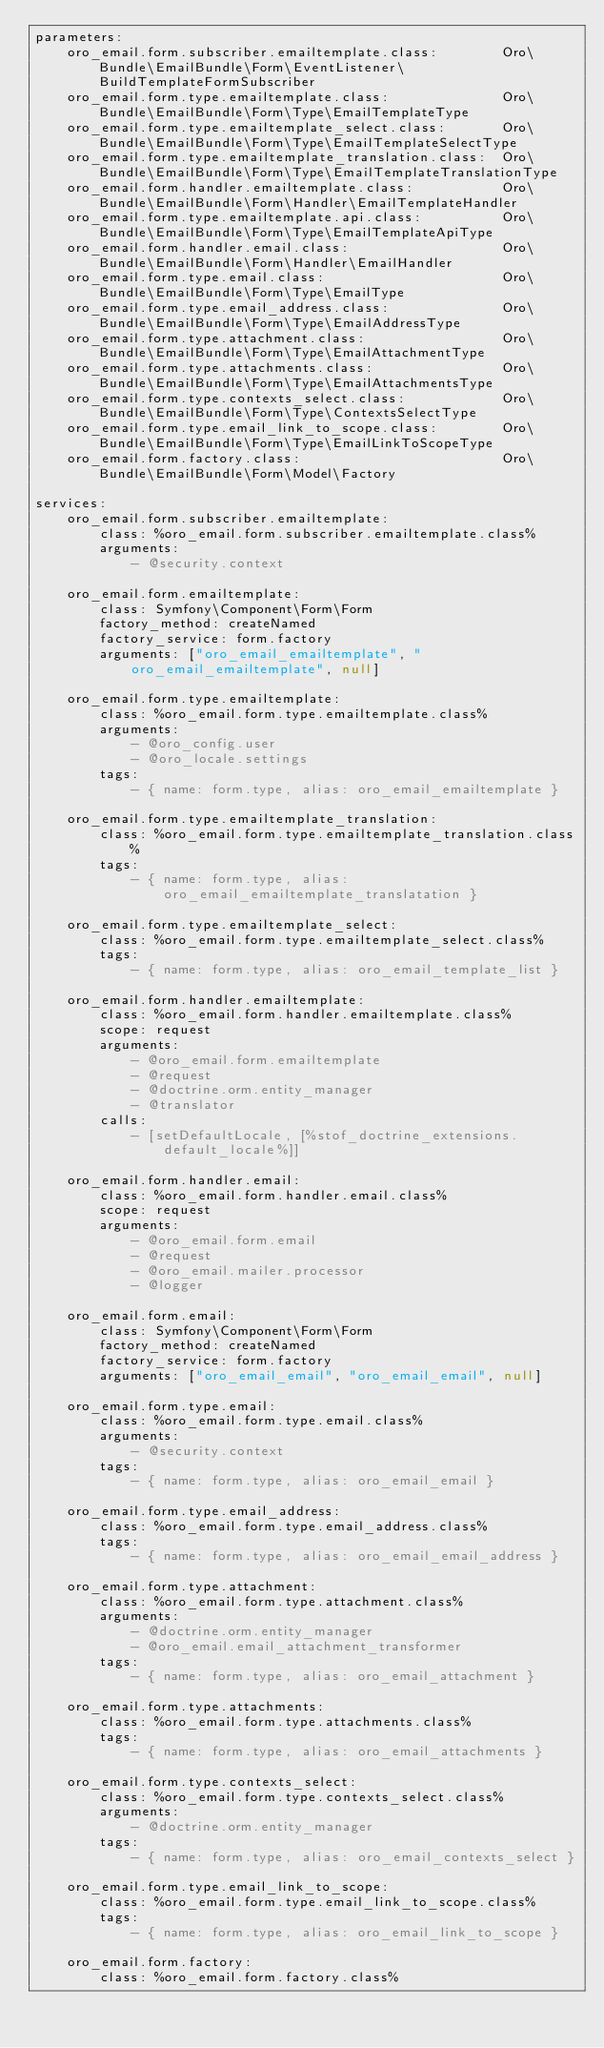<code> <loc_0><loc_0><loc_500><loc_500><_YAML_>parameters:
    oro_email.form.subscriber.emailtemplate.class:        Oro\Bundle\EmailBundle\Form\EventListener\BuildTemplateFormSubscriber
    oro_email.form.type.emailtemplate.class:              Oro\Bundle\EmailBundle\Form\Type\EmailTemplateType
    oro_email.form.type.emailtemplate_select.class:       Oro\Bundle\EmailBundle\Form\Type\EmailTemplateSelectType
    oro_email.form.type.emailtemplate_translation.class:  Oro\Bundle\EmailBundle\Form\Type\EmailTemplateTranslationType
    oro_email.form.handler.emailtemplate.class:           Oro\Bundle\EmailBundle\Form\Handler\EmailTemplateHandler
    oro_email.form.type.emailtemplate.api.class:          Oro\Bundle\EmailBundle\Form\Type\EmailTemplateApiType
    oro_email.form.handler.email.class:                   Oro\Bundle\EmailBundle\Form\Handler\EmailHandler
    oro_email.form.type.email.class:                      Oro\Bundle\EmailBundle\Form\Type\EmailType
    oro_email.form.type.email_address.class:              Oro\Bundle\EmailBundle\Form\Type\EmailAddressType
    oro_email.form.type.attachment.class:                 Oro\Bundle\EmailBundle\Form\Type\EmailAttachmentType
    oro_email.form.type.attachments.class:                Oro\Bundle\EmailBundle\Form\Type\EmailAttachmentsType
    oro_email.form.type.contexts_select.class:            Oro\Bundle\EmailBundle\Form\Type\ContextsSelectType
    oro_email.form.type.email_link_to_scope.class:        Oro\Bundle\EmailBundle\Form\Type\EmailLinkToScopeType
    oro_email.form.factory.class:                         Oro\Bundle\EmailBundle\Form\Model\Factory

services:
    oro_email.form.subscriber.emailtemplate:
        class: %oro_email.form.subscriber.emailtemplate.class%
        arguments:
            - @security.context

    oro_email.form.emailtemplate:
        class: Symfony\Component\Form\Form
        factory_method: createNamed
        factory_service: form.factory
        arguments: ["oro_email_emailtemplate", "oro_email_emailtemplate", null]

    oro_email.form.type.emailtemplate:
        class: %oro_email.form.type.emailtemplate.class%
        arguments:
            - @oro_config.user
            - @oro_locale.settings
        tags:
            - { name: form.type, alias: oro_email_emailtemplate }

    oro_email.form.type.emailtemplate_translation:
        class: %oro_email.form.type.emailtemplate_translation.class%
        tags:
            - { name: form.type, alias: oro_email_emailtemplate_translatation }

    oro_email.form.type.emailtemplate_select:
        class: %oro_email.form.type.emailtemplate_select.class%
        tags:
            - { name: form.type, alias: oro_email_template_list }

    oro_email.form.handler.emailtemplate:
        class: %oro_email.form.handler.emailtemplate.class%
        scope: request
        arguments:
            - @oro_email.form.emailtemplate
            - @request
            - @doctrine.orm.entity_manager
            - @translator
        calls:
            - [setDefaultLocale, [%stof_doctrine_extensions.default_locale%]]

    oro_email.form.handler.email:
        class: %oro_email.form.handler.email.class%
        scope: request
        arguments:
            - @oro_email.form.email
            - @request
            - @oro_email.mailer.processor
            - @logger

    oro_email.form.email:
        class: Symfony\Component\Form\Form
        factory_method: createNamed
        factory_service: form.factory
        arguments: ["oro_email_email", "oro_email_email", null]

    oro_email.form.type.email:
        class: %oro_email.form.type.email.class%
        arguments:
            - @security.context
        tags:
            - { name: form.type, alias: oro_email_email }

    oro_email.form.type.email_address:
        class: %oro_email.form.type.email_address.class%
        tags:
            - { name: form.type, alias: oro_email_email_address }

    oro_email.form.type.attachment:
        class: %oro_email.form.type.attachment.class%
        arguments:
            - @doctrine.orm.entity_manager
            - @oro_email.email_attachment_transformer
        tags:
            - { name: form.type, alias: oro_email_attachment }

    oro_email.form.type.attachments:
        class: %oro_email.form.type.attachments.class%
        tags:
            - { name: form.type, alias: oro_email_attachments }

    oro_email.form.type.contexts_select:
        class: %oro_email.form.type.contexts_select.class%
        arguments:
            - @doctrine.orm.entity_manager
        tags:
            - { name: form.type, alias: oro_email_contexts_select }

    oro_email.form.type.email_link_to_scope:
        class: %oro_email.form.type.email_link_to_scope.class%
        tags:
            - { name: form.type, alias: oro_email_link_to_scope }

    oro_email.form.factory:
        class: %oro_email.form.factory.class%
</code> 